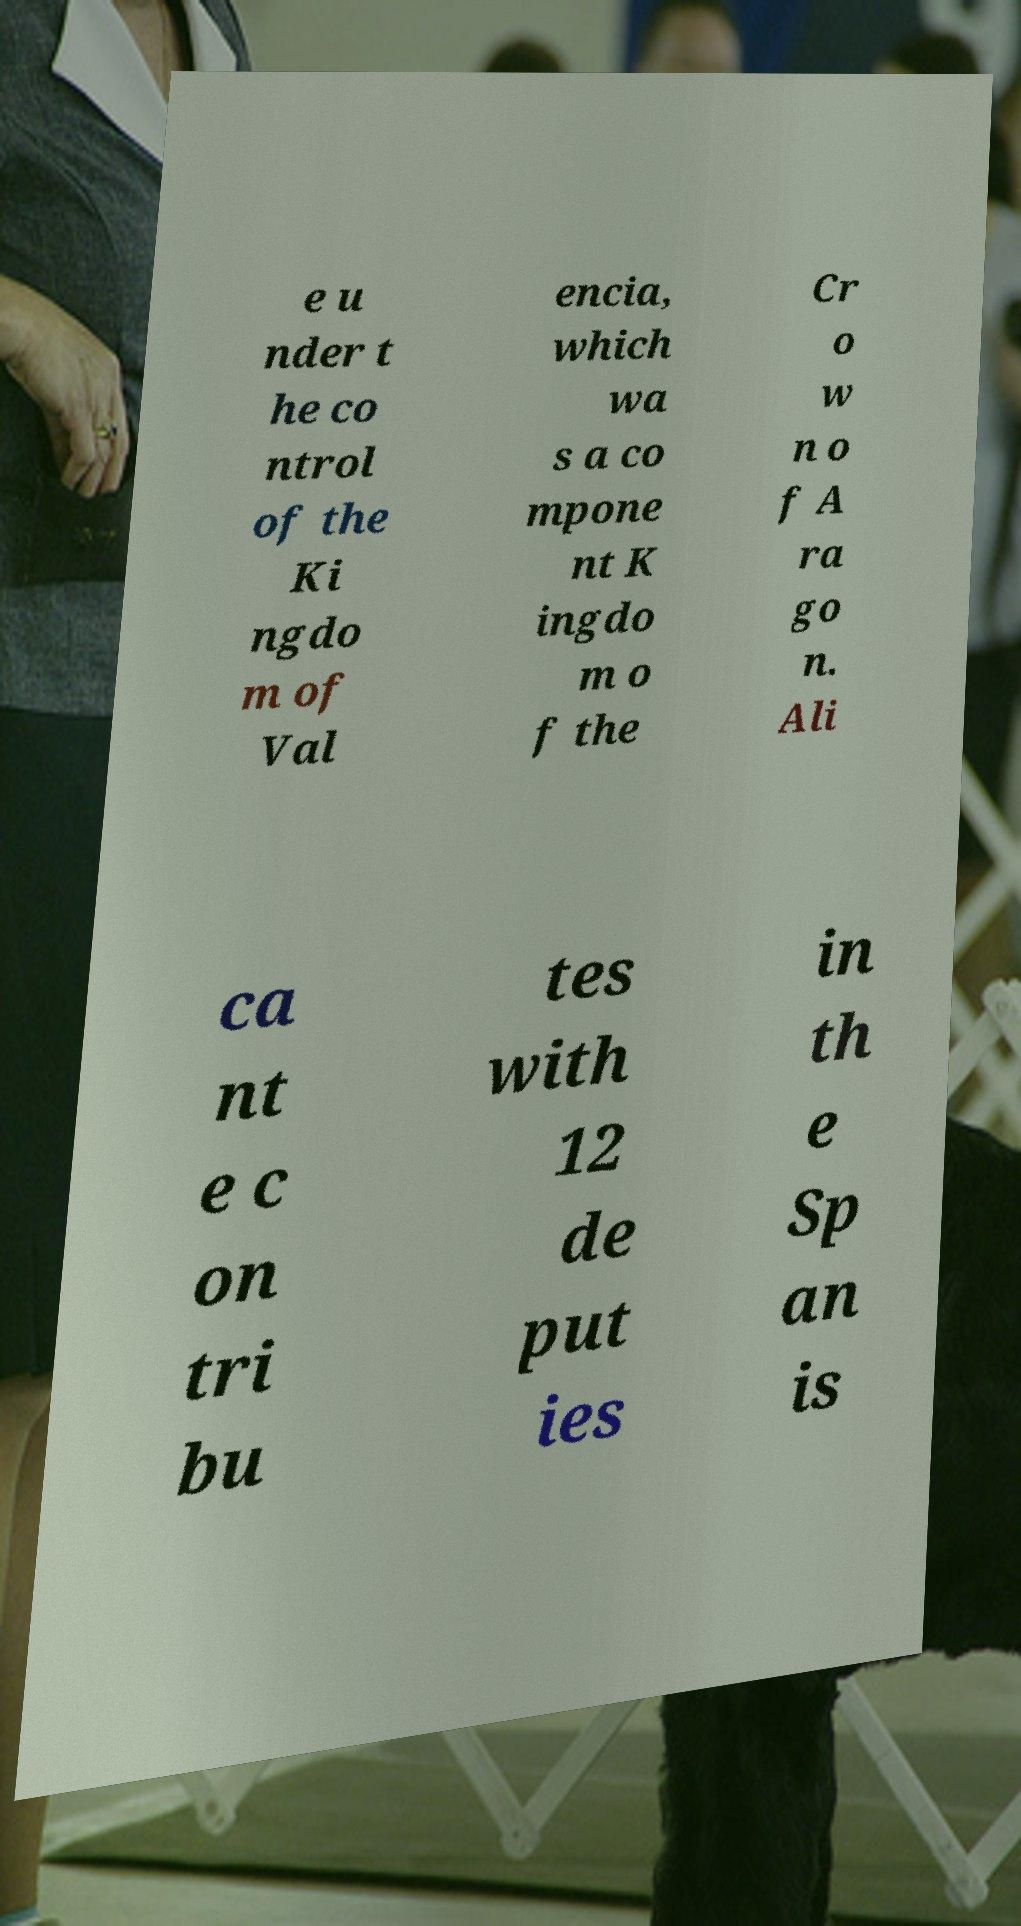There's text embedded in this image that I need extracted. Can you transcribe it verbatim? e u nder t he co ntrol of the Ki ngdo m of Val encia, which wa s a co mpone nt K ingdo m o f the Cr o w n o f A ra go n. Ali ca nt e c on tri bu tes with 12 de put ies in th e Sp an is 